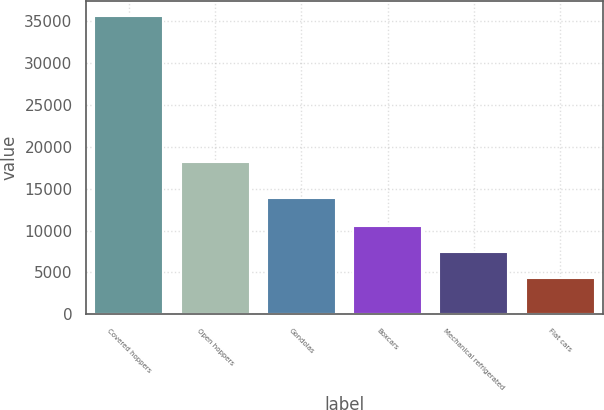Convert chart to OTSL. <chart><loc_0><loc_0><loc_500><loc_500><bar_chart><fcel>Covered hoppers<fcel>Open hoppers<fcel>Gondolas<fcel>Boxcars<fcel>Mechanical refrigerated<fcel>Flat cars<nl><fcel>35655<fcel>18134<fcel>13923<fcel>10591<fcel>7458<fcel>4325<nl></chart> 